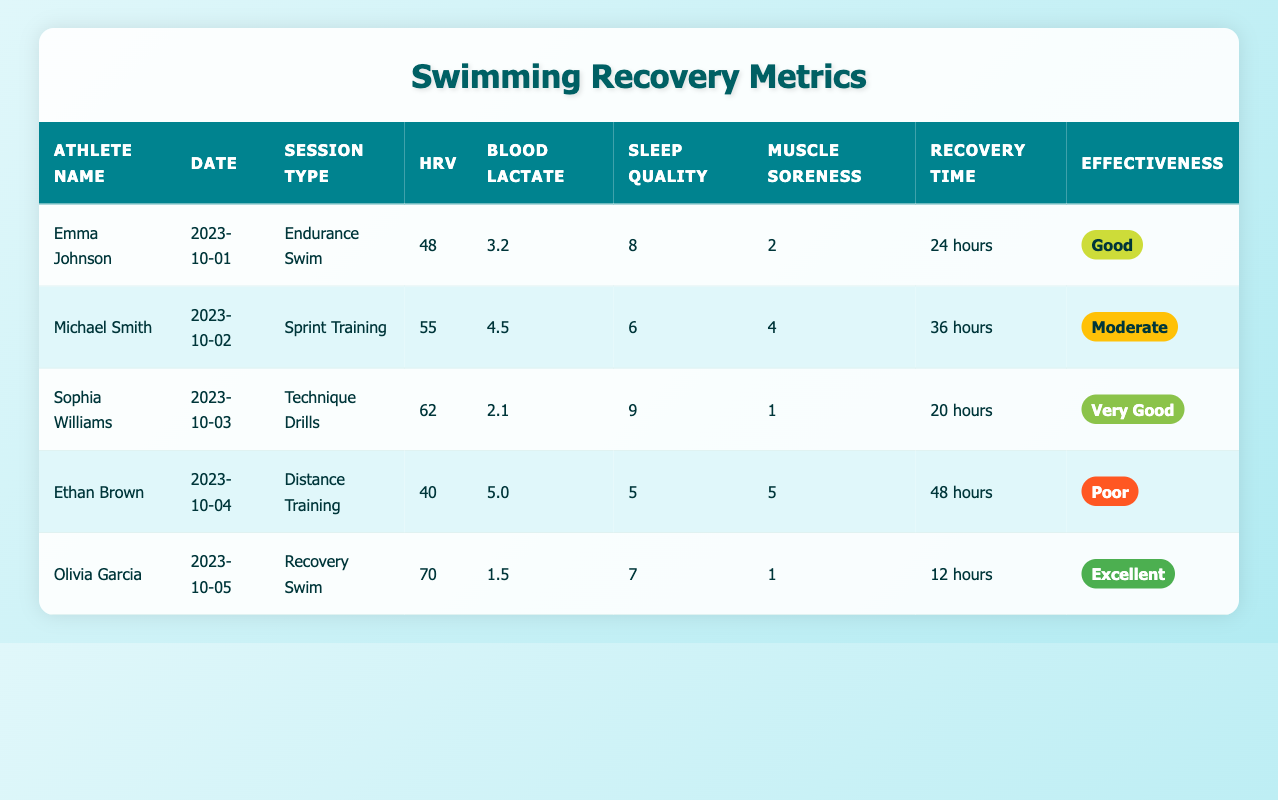What is the heart rate variability of Emma Johnson? The table shows that Emma Johnson's heart rate variability (HRV) is listed as 48.
Answer: 48 Which athlete had the highest sleep quality score and what was it? Looking through the table, the highest sleep quality score is 9, which belongs to Sophia Williams.
Answer: 9 How many hours of recovery time did Michael Smith need after his training session? The table indicates that Michael Smith required 36 hours of recovery time after his training session.
Answer: 36 hours Is Ethan Brown's effectiveness rating poor? According to the table, Ethan Brown's effectiveness rating is listed as "Poor," confirming that the statement is true.
Answer: Yes What is the difference in blood lactate levels between Emma Johnson and Ethan Brown? Emma Johnson has a blood lactate level of 3.2, while Ethan Brown has a level of 5.0. The difference can be calculated as 5.0 - 3.2 = 1.8.
Answer: 1.8 What is the average recovery time for all athletes listed? The sum of recovery times is 24 + 36 + 20 + 48 + 12 = 140 hours. There are 5 athletes, so the average recovery time is 140 / 5 = 28 hours.
Answer: 28 hours Did Olivia Garcia have a lower muscle soreness score compared to Sophia Williams? Olivia Garcia's muscle soreness score is 1, and Sophia Williams' score is 1 as well. Since they are equal, Olivia did not have a lower score.
Answer: No Which athlete had the most effective session and how was it rated? The table shows that Olivia Garcia had the most effective session rated as "Excellent."
Answer: Excellent How many athletes had an effectiveness rating of Good or better? Looking through the table, Emma Johnson, Sophia Williams, and Olivia Garcia have ratings of "Good," "Very Good," and "Excellent," respectively. This totals to 3 athletes with Good or better effectiveness.
Answer: 3 